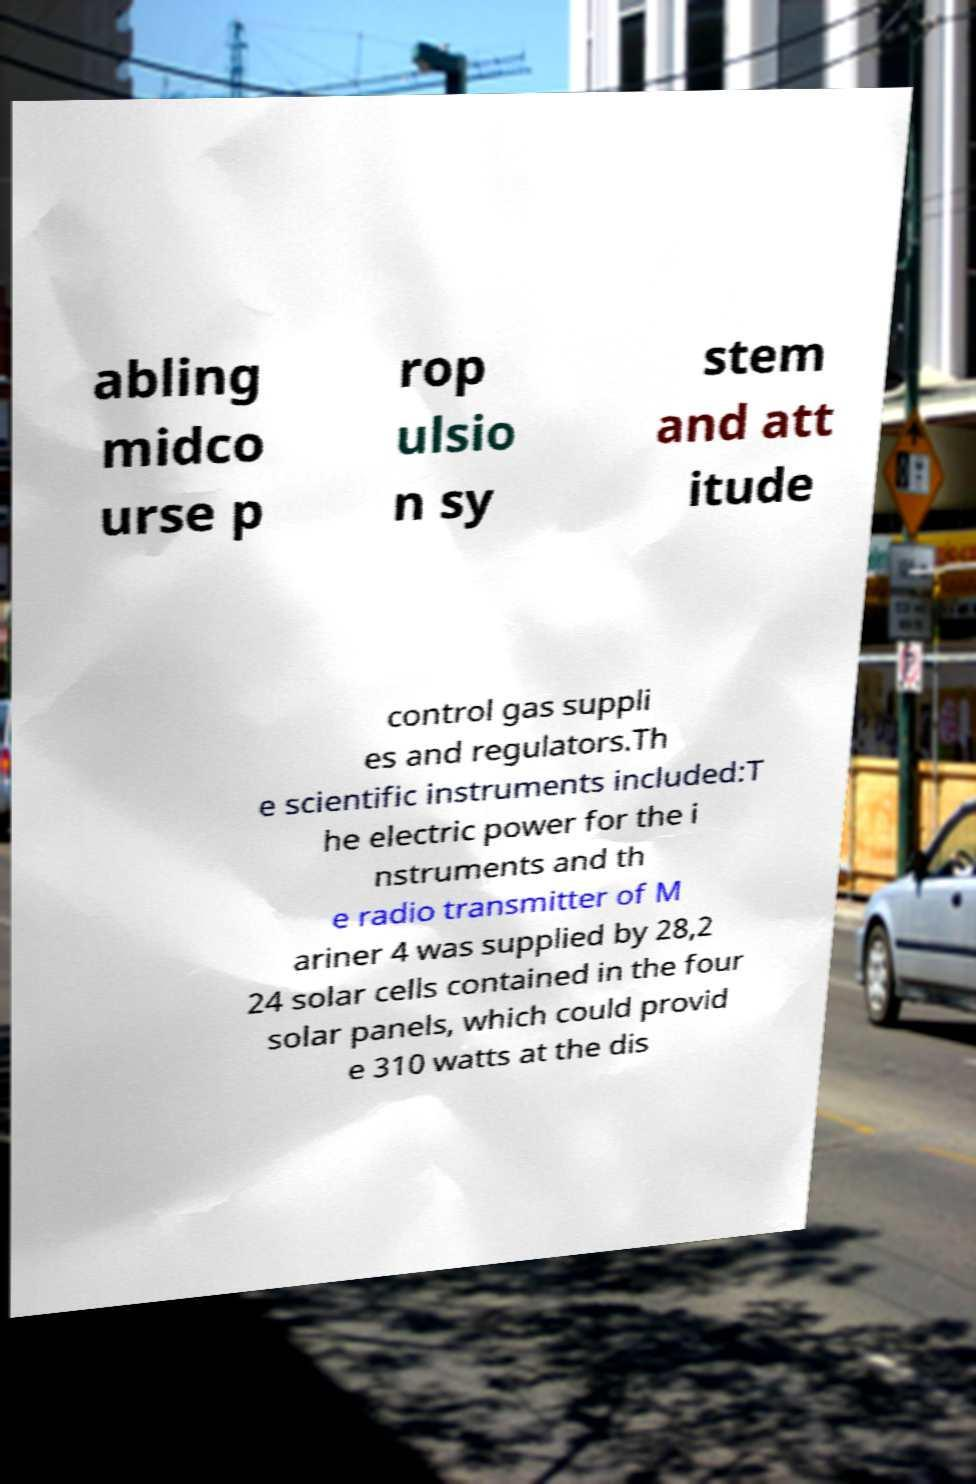For documentation purposes, I need the text within this image transcribed. Could you provide that? abling midco urse p rop ulsio n sy stem and att itude control gas suppli es and regulators.Th e scientific instruments included:T he electric power for the i nstruments and th e radio transmitter of M ariner 4 was supplied by 28,2 24 solar cells contained in the four solar panels, which could provid e 310 watts at the dis 